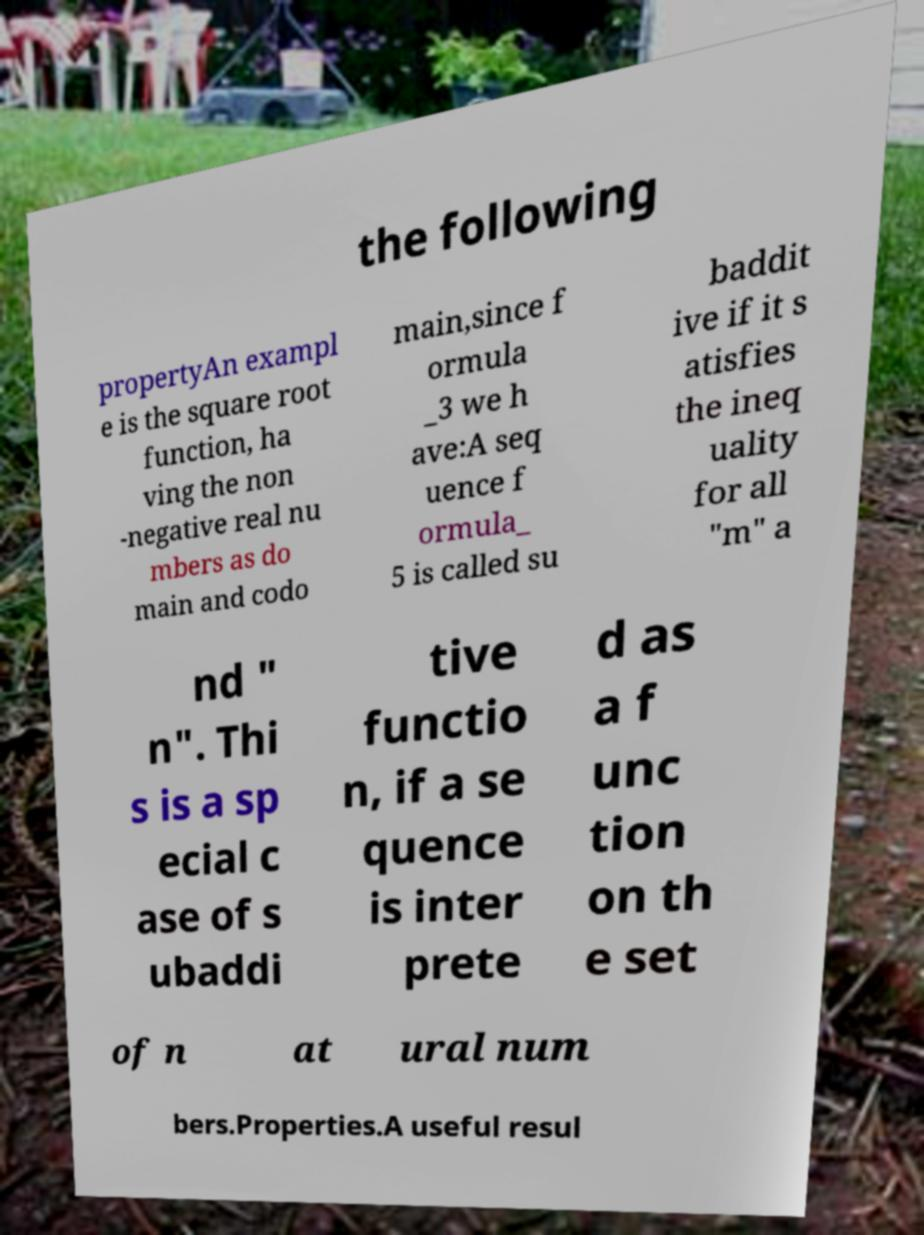Can you accurately transcribe the text from the provided image for me? the following propertyAn exampl e is the square root function, ha ving the non -negative real nu mbers as do main and codo main,since f ormula _3 we h ave:A seq uence f ormula_ 5 is called su baddit ive if it s atisfies the ineq uality for all "m" a nd " n". Thi s is a sp ecial c ase of s ubaddi tive functio n, if a se quence is inter prete d as a f unc tion on th e set of n at ural num bers.Properties.A useful resul 